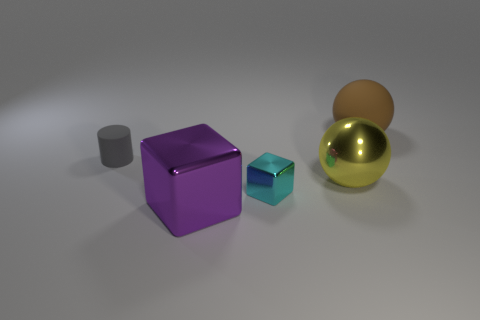What size is the rubber object in front of the large thing that is behind the small gray cylinder?
Your response must be concise. Small. What number of small cyan objects have the same shape as the big purple shiny thing?
Your answer should be compact. 1. Is the color of the rubber cylinder the same as the metallic ball?
Make the answer very short. No. Is there any other thing that has the same shape as the tiny gray thing?
Provide a short and direct response. No. Is there another object that has the same color as the tiny matte object?
Make the answer very short. No. Are the tiny thing to the left of the purple thing and the tiny object right of the large metallic cube made of the same material?
Keep it short and to the point. No. The large shiny sphere has what color?
Keep it short and to the point. Yellow. What is the size of the matte object right of the sphere that is left of the matte thing that is right of the big purple block?
Your response must be concise. Large. What number of other objects are the same size as the gray object?
Keep it short and to the point. 1. How many large balls have the same material as the yellow object?
Ensure brevity in your answer.  0. 